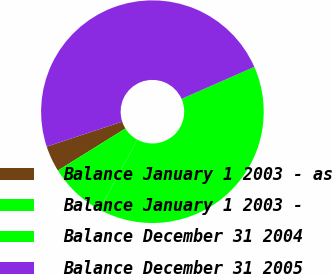<chart> <loc_0><loc_0><loc_500><loc_500><pie_chart><fcel>Balance January 1 2003 - as<fcel>Balance January 1 2003 -<fcel>Balance December 31 2004<fcel>Balance December 31 2005<nl><fcel>3.78%<fcel>8.25%<fcel>39.48%<fcel>48.48%<nl></chart> 